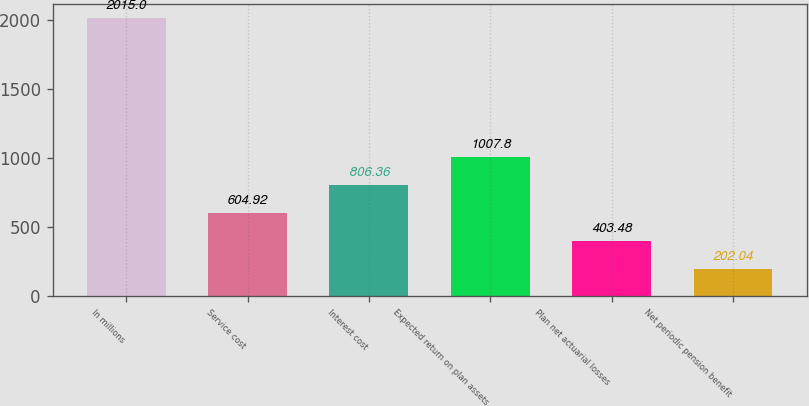<chart> <loc_0><loc_0><loc_500><loc_500><bar_chart><fcel>In millions<fcel>Service cost<fcel>Interest cost<fcel>Expected return on plan assets<fcel>Plan net actuarial losses<fcel>Net periodic pension benefit<nl><fcel>2015<fcel>604.92<fcel>806.36<fcel>1007.8<fcel>403.48<fcel>202.04<nl></chart> 